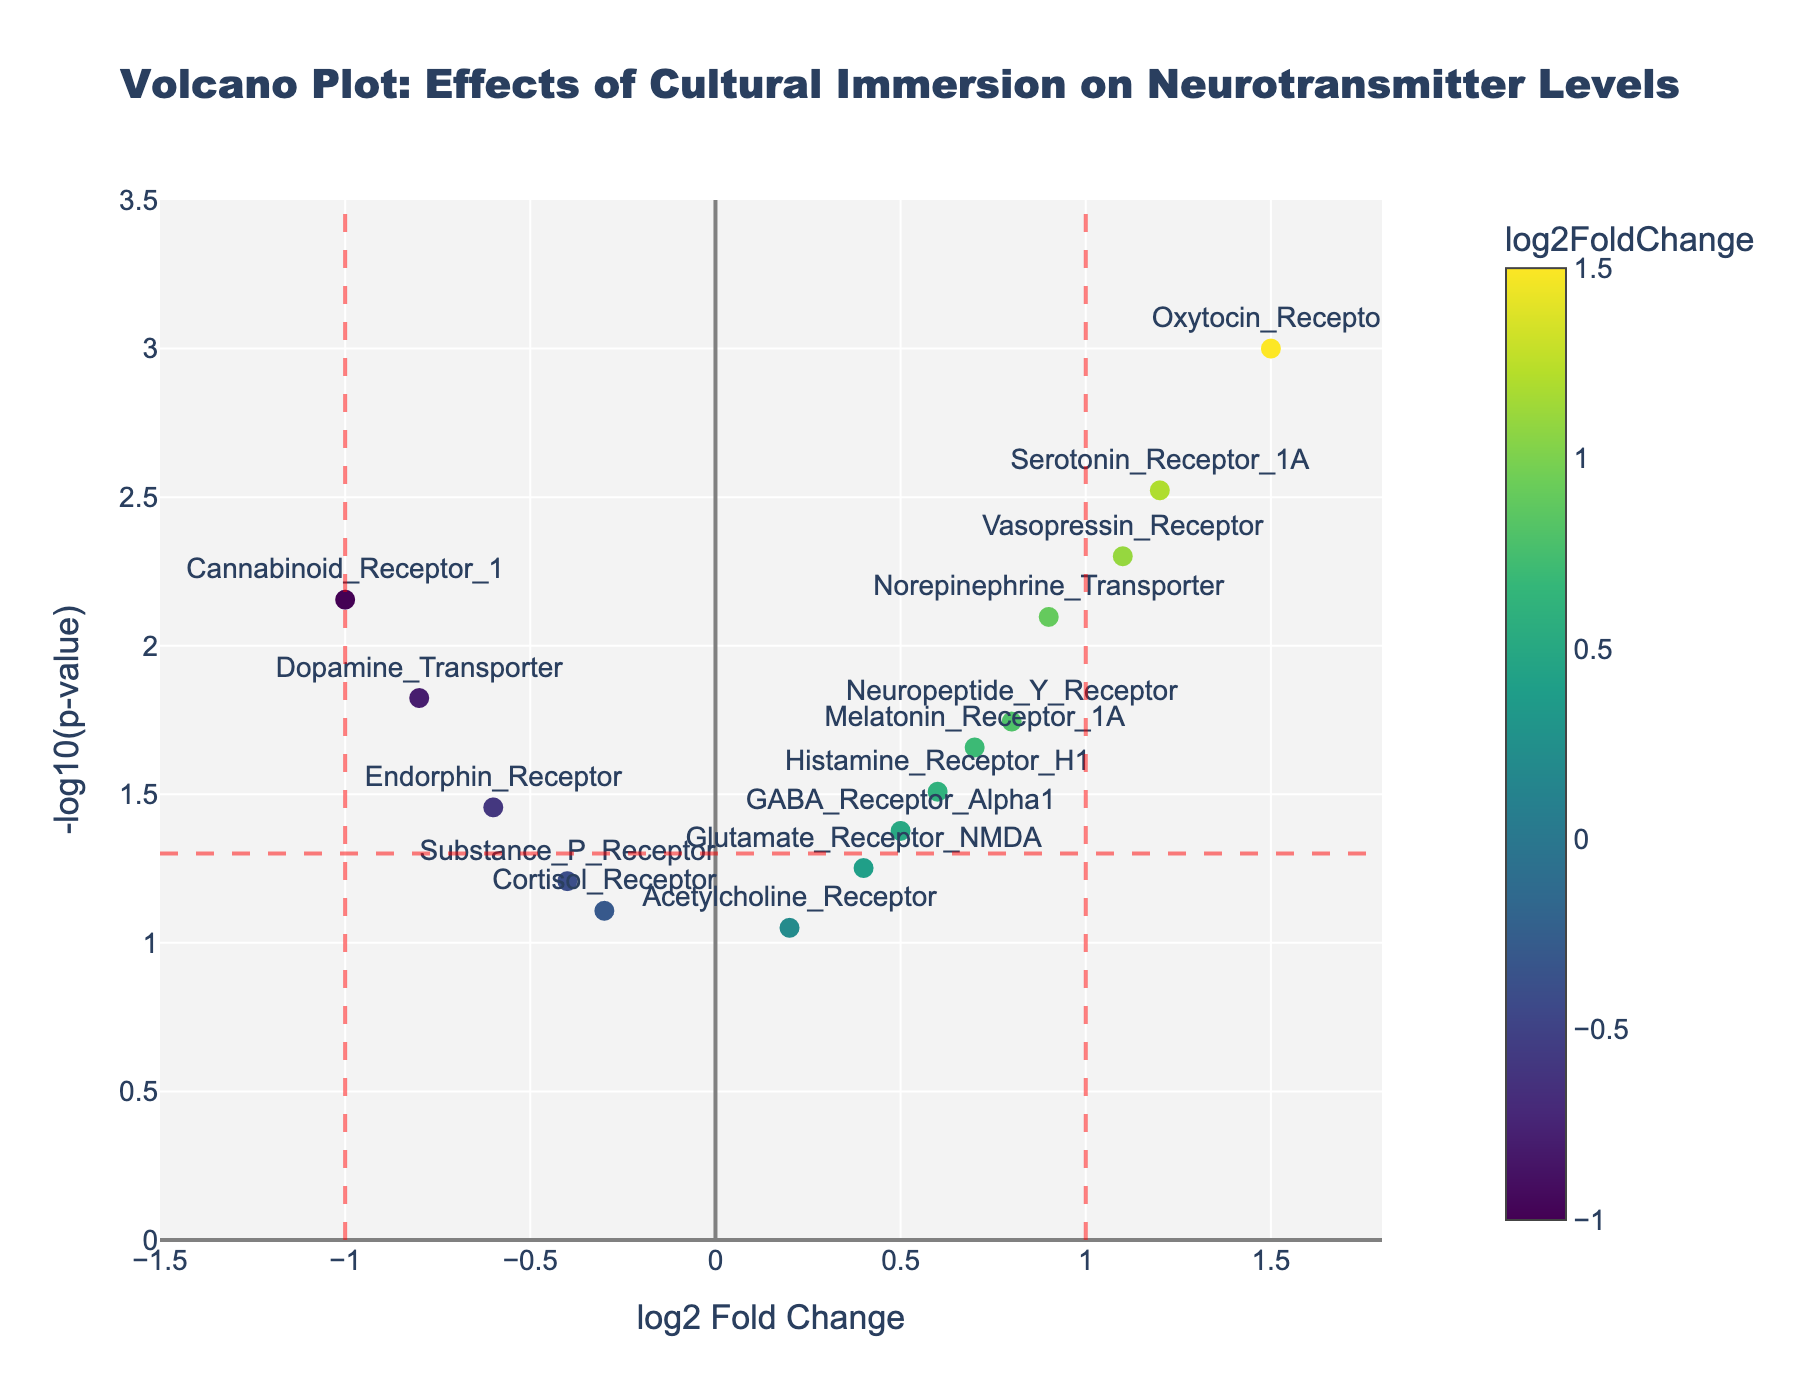What is the title of the plot? The title is the text displayed at the top of the plot, summarizing its main focus or theme. In this case, the title provided in the layout settings gives an overview of the study's main subject.
Answer: "Volcano Plot: Effects of Cultural Immersion on Neurotransmitter Levels" What do the x-axis and y-axis represent in the plot? The x-axis is labeled "log2 Fold Change", indicating the change in neurotransmitter levels between the study groups on a log2 scale. The y-axis is labeled "-log10(p-value)", representing the statistical significance of those changes, with lower p-values shown as higher values.
Answer: log2 Fold Change and -log10(p-value) How many neurotransmitter genes have a -log10(p-value) greater than 1.3? A -log10(p-value) greater than 1.3 corresponds to a p-value less than 0.05. Count the data points with a y-value above 1.3 to find the number of significant neurotransmitter genes.
Answer: 11 Which neurotransmitter receptor has the highest log2 Fold Change? Examine the x-axis values and find the highest point along the right-hand side of the x-axis labeled with the corresponding gene name.
Answer: Oxytocin_Receptor Which neurotransmitter receptor has the lowest log2 Fold Change? Identify the lowest x-axis value and find the corresponding neurotransmitter gene labeled at this point on the left-hand side of the x-axis.
Answer: Cannabinoid_Receptor_1 Which neurotransmitter gene's p-value is closest to the significance threshold of 0.05? The significance threshold line at 1.3 (-log10(0.05)) helps identify genes close to this value. Locate the gene situated closest to this horizontal line.
Answer: Substance_P_Receptor How many genes show a log2 Fold Change greater than 1 and are statistically significant (p-value < 0.05)? Find genes with a log2 Fold Change above 1 and a -log10(p-value) above 1.3. These points should be denoted using separate color markers along the x-axis and above the horizontal threshold line.
Answer: 3 Compare the log2 Fold Change of the Serotonin_Receptor_1A and the Dopamine_Transporter. Which is larger? Locate the markers for Serotonin_Receptor_1A and Dopamine_Transporter on the x-axis and compare their values to see which one is larger.
Answer: Serotonin_Receptor_1A Which neurotransmitter receptor has the highest statistical significance? The highest statistical significance corresponds to the highest -log10(p-value) value. Identify the peak data point on the y-axis and note the relevant neurotransmitter gene.
Answer: Oxytocin_Receptor 